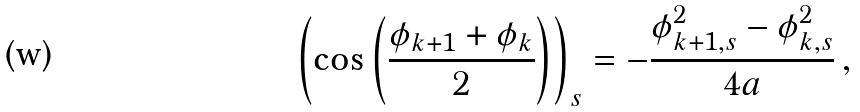Convert formula to latex. <formula><loc_0><loc_0><loc_500><loc_500>\left ( \cos \left ( \frac { \phi _ { k + 1 } + \phi _ { k } } { 2 } \right ) \right ) _ { s } = - \frac { \phi _ { k + 1 , s } ^ { 2 } - \phi _ { k , s } ^ { 2 } } { 4 a } \, ,</formula> 